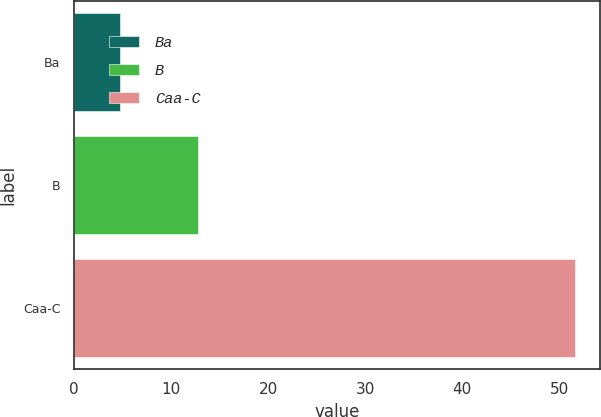Convert chart to OTSL. <chart><loc_0><loc_0><loc_500><loc_500><bar_chart><fcel>Ba<fcel>B<fcel>Caa-C<nl><fcel>4.8<fcel>12.8<fcel>51.6<nl></chart> 